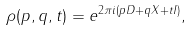<formula> <loc_0><loc_0><loc_500><loc_500>\rho ( p , q , t ) = e ^ { 2 \pi i ( p D + q X + t I ) } ,</formula> 